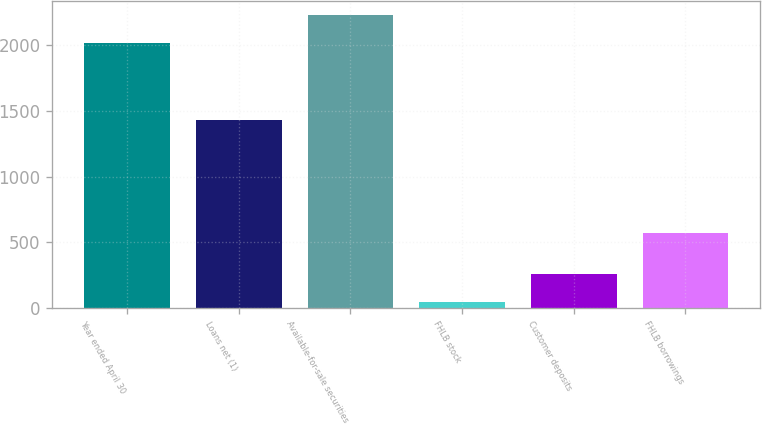Convert chart. <chart><loc_0><loc_0><loc_500><loc_500><bar_chart><fcel>Year ended April 30<fcel>Loans net (1)<fcel>Available-for-sale securities<fcel>FHLB stock<fcel>Customer deposits<fcel>FHLB borrowings<nl><fcel>2013<fcel>1432<fcel>2225.1<fcel>45<fcel>263<fcel>573<nl></chart> 